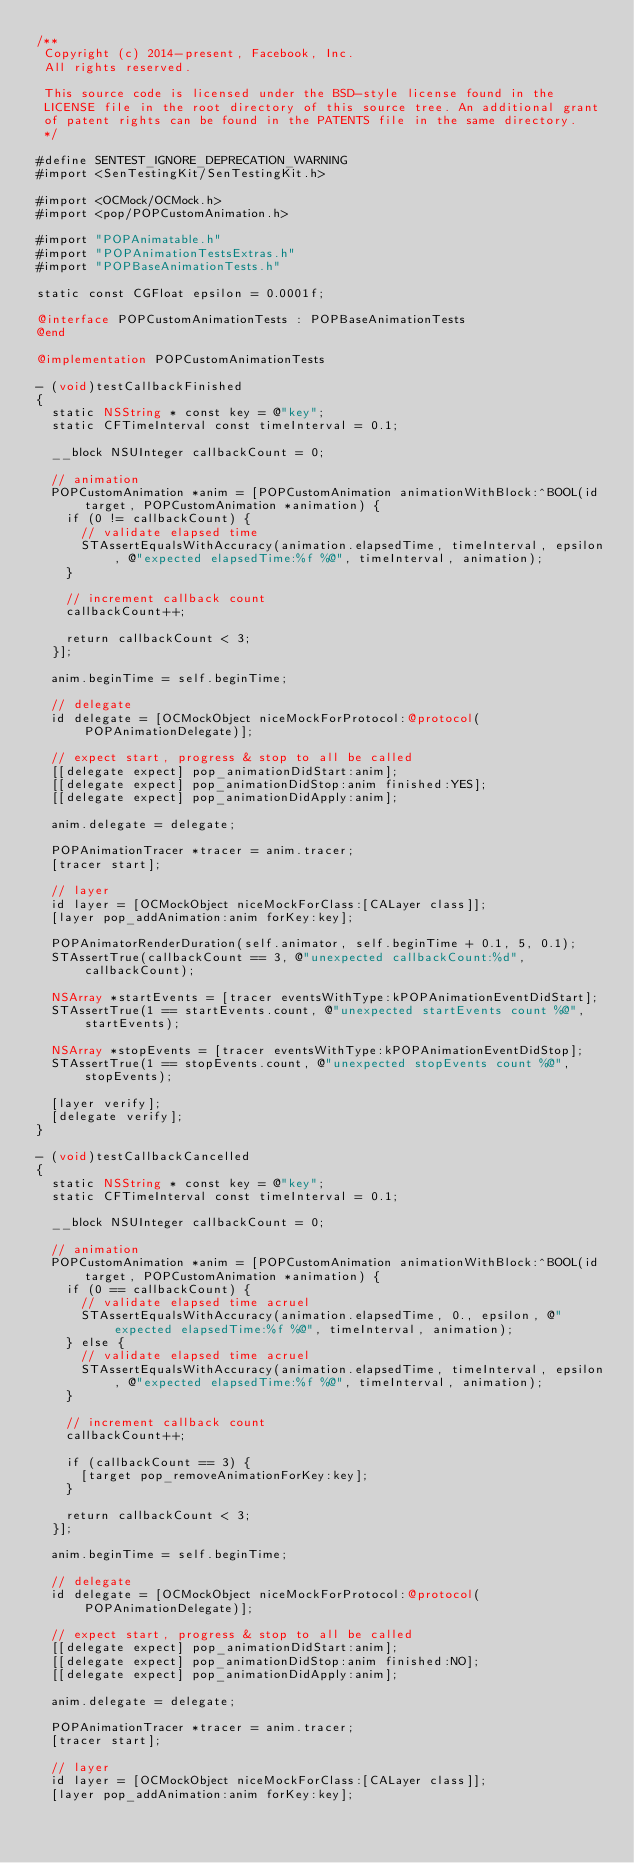Convert code to text. <code><loc_0><loc_0><loc_500><loc_500><_ObjectiveC_>/**
 Copyright (c) 2014-present, Facebook, Inc.
 All rights reserved.
 
 This source code is licensed under the BSD-style license found in the
 LICENSE file in the root directory of this source tree. An additional grant
 of patent rights can be found in the PATENTS file in the same directory.
 */

#define SENTEST_IGNORE_DEPRECATION_WARNING
#import <SenTestingKit/SenTestingKit.h>

#import <OCMock/OCMock.h>
#import <pop/POPCustomAnimation.h>

#import "POPAnimatable.h"
#import "POPAnimationTestsExtras.h"
#import "POPBaseAnimationTests.h"

static const CGFloat epsilon = 0.0001f;

@interface POPCustomAnimationTests : POPBaseAnimationTests
@end

@implementation POPCustomAnimationTests

- (void)testCallbackFinished
{
  static NSString * const key = @"key";
  static CFTimeInterval const timeInterval = 0.1;

  __block NSUInteger callbackCount = 0;
  
  // animation
  POPCustomAnimation *anim = [POPCustomAnimation animationWithBlock:^BOOL(id target, POPCustomAnimation *animation) {
    if (0 != callbackCount) {
      // validate elapsed time
      STAssertEqualsWithAccuracy(animation.elapsedTime, timeInterval, epsilon, @"expected elapsedTime:%f %@", timeInterval, animation);
    }

    // increment callback count
    callbackCount++;

    return callbackCount < 3;
  }];

  anim.beginTime = self.beginTime;
  
  // delegate
  id delegate = [OCMockObject niceMockForProtocol:@protocol(POPAnimationDelegate)];
  
  // expect start, progress & stop to all be called
  [[delegate expect] pop_animationDidStart:anim];
  [[delegate expect] pop_animationDidStop:anim finished:YES];
  [[delegate expect] pop_animationDidApply:anim];
  
  anim.delegate = delegate;

  POPAnimationTracer *tracer = anim.tracer;
  [tracer start];
  
  // layer
  id layer = [OCMockObject niceMockForClass:[CALayer class]];
  [layer pop_addAnimation:anim forKey:key];
  
  POPAnimatorRenderDuration(self.animator, self.beginTime + 0.1, 5, 0.1);
  STAssertTrue(callbackCount == 3, @"unexpected callbackCount:%d", callbackCount);
  
  NSArray *startEvents = [tracer eventsWithType:kPOPAnimationEventDidStart];
  STAssertTrue(1 == startEvents.count, @"unexpected startEvents count %@", startEvents);
  
  NSArray *stopEvents = [tracer eventsWithType:kPOPAnimationEventDidStop];
  STAssertTrue(1 == stopEvents.count, @"unexpected stopEvents count %@", stopEvents);

  [layer verify];
  [delegate verify];
}

- (void)testCallbackCancelled
{
  static NSString * const key = @"key";
  static CFTimeInterval const timeInterval = 0.1;
  
  __block NSUInteger callbackCount = 0;
  
  // animation
  POPCustomAnimation *anim = [POPCustomAnimation animationWithBlock:^BOOL(id target, POPCustomAnimation *animation) {
    if (0 == callbackCount) {
      // validate elapsed time acruel
      STAssertEqualsWithAccuracy(animation.elapsedTime, 0., epsilon, @"expected elapsedTime:%f %@", timeInterval, animation);
    } else {
      // validate elapsed time acruel
      STAssertEqualsWithAccuracy(animation.elapsedTime, timeInterval, epsilon, @"expected elapsedTime:%f %@", timeInterval, animation);
    }
    
    // increment callback count
    callbackCount++;
    
    if (callbackCount == 3) {
      [target pop_removeAnimationForKey:key];
    }
    
    return callbackCount < 3;
  }];
  
  anim.beginTime = self.beginTime;
  
  // delegate
  id delegate = [OCMockObject niceMockForProtocol:@protocol(POPAnimationDelegate)];
  
  // expect start, progress & stop to all be called
  [[delegate expect] pop_animationDidStart:anim];
  [[delegate expect] pop_animationDidStop:anim finished:NO];
  [[delegate expect] pop_animationDidApply:anim];
  
  anim.delegate = delegate;
  
  POPAnimationTracer *tracer = anim.tracer;
  [tracer start];

  // layer
  id layer = [OCMockObject niceMockForClass:[CALayer class]];
  [layer pop_addAnimation:anim forKey:key];
  </code> 